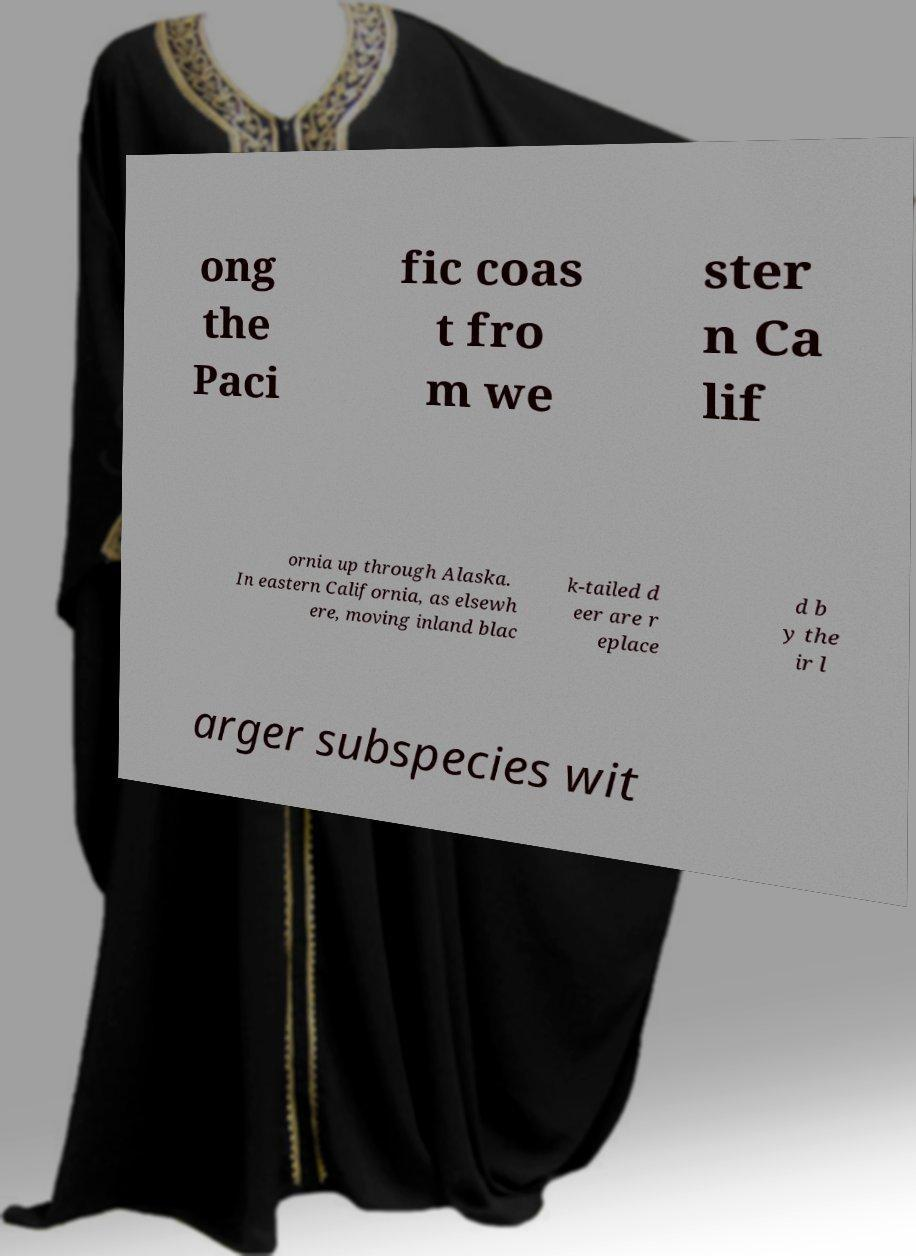Can you accurately transcribe the text from the provided image for me? ong the Paci fic coas t fro m we ster n Ca lif ornia up through Alaska. In eastern California, as elsewh ere, moving inland blac k-tailed d eer are r eplace d b y the ir l arger subspecies wit 